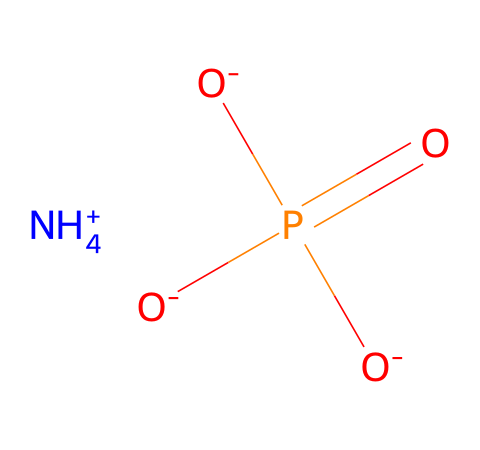What is the molecular formula of this ionic liquid? The SMILES representation indicates the presence of ammonium ion (NH4+) and a phosphate ion (PO4^3-). Counting the atoms gives a formula of NH4O4P.
Answer: NH4O4P How many oxygen atoms are present in this ionic liquid? From the SMILES, we see three oxygen atoms in the phosphate part and one additional oxygen in the ammonium context, totaling four oxygen atoms.
Answer: four What type of function does the ammonium ion serve in this ionic liquid? The ammonium ion (NH4+) acts as a cation, which is positive and helps balance the negatively charged phosphate anion (O-). This enables the ionic liquid to dissolve in solvents and increases its solubility.
Answer: cation What is the charge on the phosphate part of this ionic liquid? The phosphate group in the structure has a -3 charge due to the three negatively charged oxygen atoms that accept protons. Thus, the phosphate ion is represented as PO4^3-.
Answer: -3 How many total atoms are in this ionic liquid structure? By counting all the unique atoms in the SMILES: 1 nitrogen, 4 hydrogens, 1 phosphorus, and 4 oxygens, we get a total of ten atoms (1+4+1+4).
Answer: ten What property of this ionic liquid helps enhance soil? Ionic liquids, due to their high conductivity and ability to retain moisture, improve nutrient availability and promote plant growth. The structure helps with ionic exchange in soil.
Answer: moisture retention 